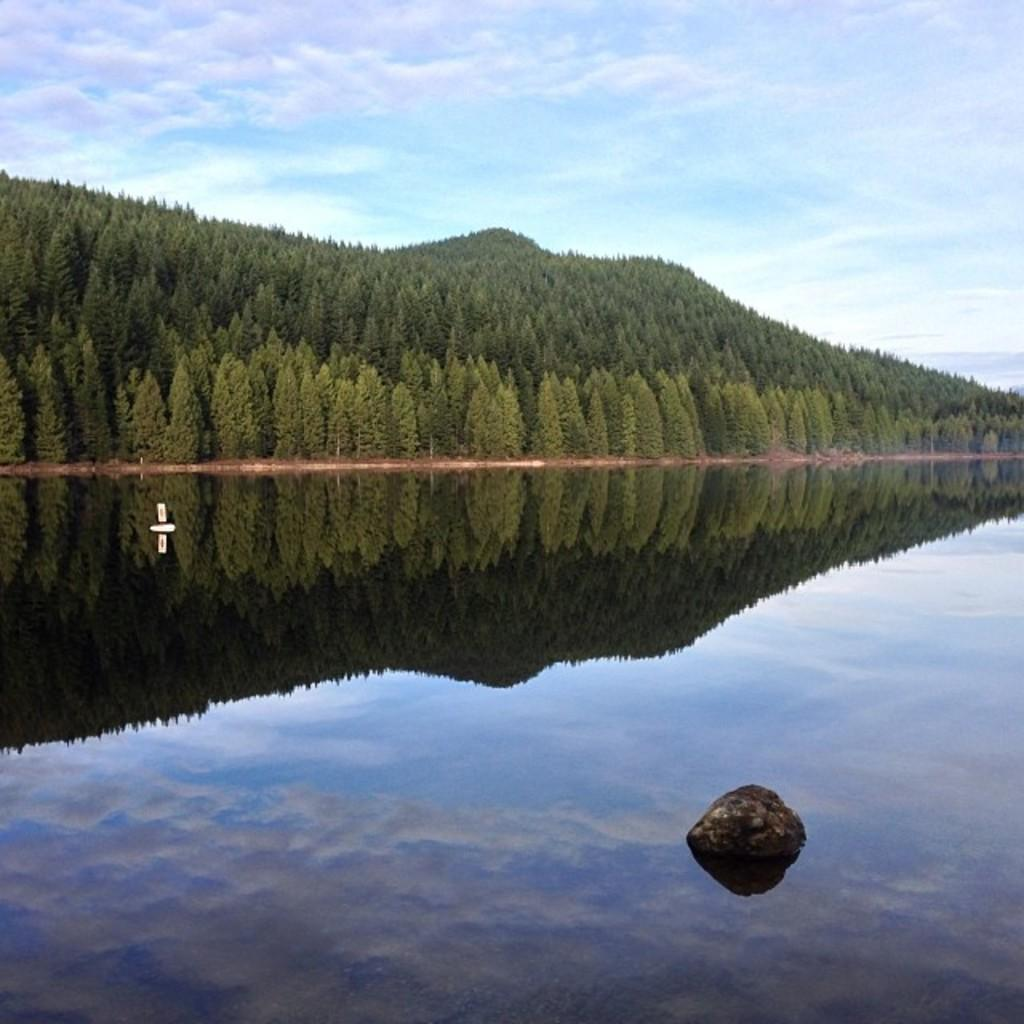What is located in the river in the image? There is a rock in the river in the image. What type of vegetation can be seen in the image? There are trees visible in the image. What part of the natural environment is visible in the image? The sky is visible in the image. What can be observed in the river besides the rock? The reflection of trees and the sky is visible in the river. What type of linen can be seen hanging on the trees in the image? There is no linen visible in the image; only trees, a rock, and reflections are present. 